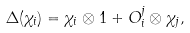<formula> <loc_0><loc_0><loc_500><loc_500>\Delta ( \chi _ { i } ) = \chi _ { i } \otimes 1 + O _ { i } ^ { j } \otimes \chi _ { j } ,</formula> 